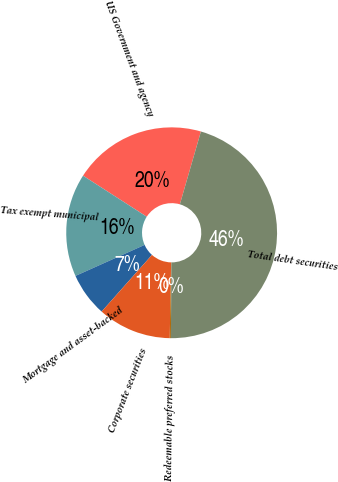Convert chart. <chart><loc_0><loc_0><loc_500><loc_500><pie_chart><fcel>US Government and agency<fcel>Tax exempt municipal<fcel>Mortgage and asset-backed<fcel>Corporate securities<fcel>Redeemable preferred stocks<fcel>Total debt securities<nl><fcel>20.37%<fcel>15.82%<fcel>6.73%<fcel>11.27%<fcel>0.17%<fcel>45.64%<nl></chart> 